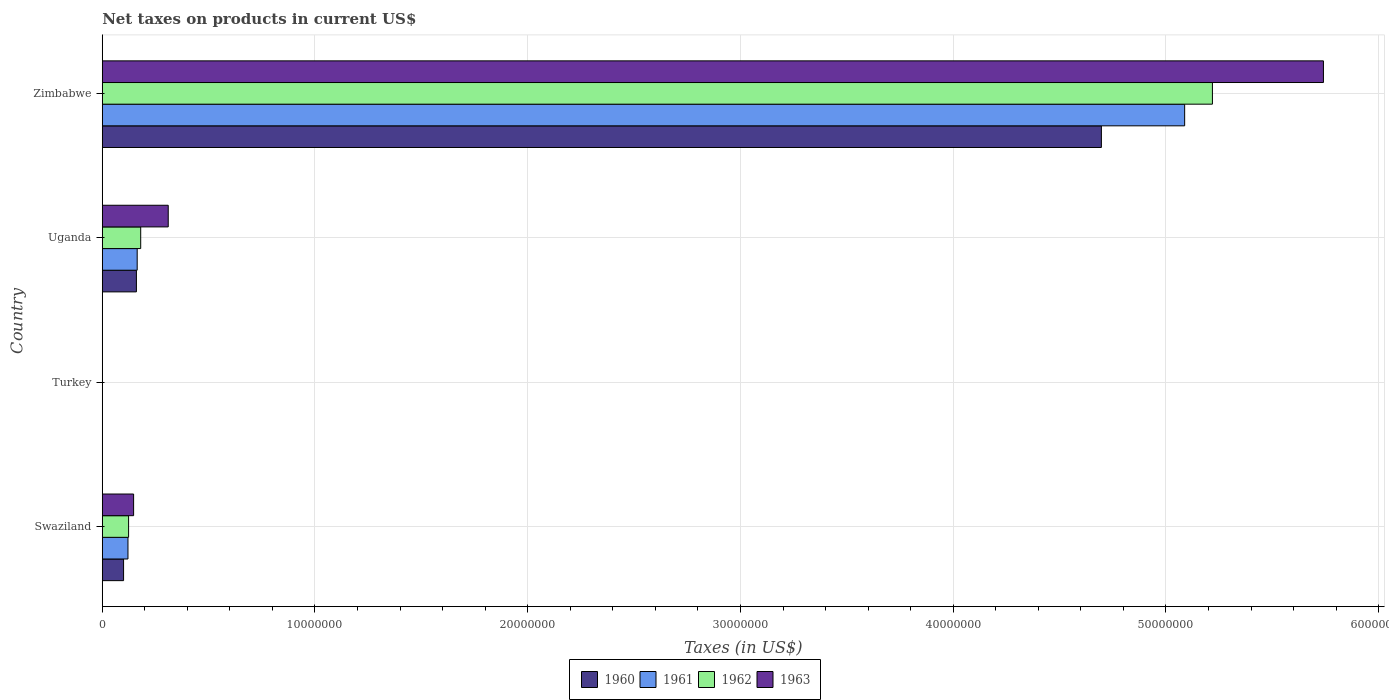How many different coloured bars are there?
Offer a terse response. 4. Are the number of bars per tick equal to the number of legend labels?
Keep it short and to the point. Yes. Are the number of bars on each tick of the Y-axis equal?
Offer a terse response. Yes. How many bars are there on the 1st tick from the top?
Make the answer very short. 4. What is the label of the 2nd group of bars from the top?
Give a very brief answer. Uganda. What is the net taxes on products in 1962 in Turkey?
Your answer should be compact. 1600. Across all countries, what is the maximum net taxes on products in 1963?
Provide a short and direct response. 5.74e+07. Across all countries, what is the minimum net taxes on products in 1960?
Offer a terse response. 1300. In which country was the net taxes on products in 1962 maximum?
Offer a terse response. Zimbabwe. What is the total net taxes on products in 1963 in the graph?
Offer a very short reply. 6.20e+07. What is the difference between the net taxes on products in 1963 in Swaziland and that in Zimbabwe?
Your answer should be very brief. -5.59e+07. What is the difference between the net taxes on products in 1963 in Zimbabwe and the net taxes on products in 1961 in Turkey?
Provide a succinct answer. 5.74e+07. What is the average net taxes on products in 1963 per country?
Your answer should be very brief. 1.55e+07. What is the difference between the net taxes on products in 1963 and net taxes on products in 1962 in Swaziland?
Offer a very short reply. 2.36e+05. In how many countries, is the net taxes on products in 1961 greater than 34000000 US$?
Your answer should be compact. 1. What is the ratio of the net taxes on products in 1963 in Swaziland to that in Uganda?
Your response must be concise. 0.48. What is the difference between the highest and the second highest net taxes on products in 1960?
Your answer should be very brief. 4.54e+07. What is the difference between the highest and the lowest net taxes on products in 1963?
Offer a very short reply. 5.74e+07. Is the sum of the net taxes on products in 1961 in Turkey and Zimbabwe greater than the maximum net taxes on products in 1962 across all countries?
Your answer should be very brief. No. Is it the case that in every country, the sum of the net taxes on products in 1963 and net taxes on products in 1960 is greater than the sum of net taxes on products in 1962 and net taxes on products in 1961?
Provide a short and direct response. No. What does the 2nd bar from the top in Zimbabwe represents?
Provide a short and direct response. 1962. What does the 2nd bar from the bottom in Swaziland represents?
Give a very brief answer. 1961. Is it the case that in every country, the sum of the net taxes on products in 1960 and net taxes on products in 1961 is greater than the net taxes on products in 1963?
Give a very brief answer. Yes. How many bars are there?
Offer a very short reply. 16. Are all the bars in the graph horizontal?
Your answer should be compact. Yes. How many countries are there in the graph?
Make the answer very short. 4. What is the difference between two consecutive major ticks on the X-axis?
Ensure brevity in your answer.  1.00e+07. Does the graph contain grids?
Offer a terse response. Yes. Where does the legend appear in the graph?
Your answer should be compact. Bottom center. How many legend labels are there?
Offer a very short reply. 4. How are the legend labels stacked?
Your answer should be compact. Horizontal. What is the title of the graph?
Provide a short and direct response. Net taxes on products in current US$. Does "1991" appear as one of the legend labels in the graph?
Make the answer very short. No. What is the label or title of the X-axis?
Your answer should be very brief. Taxes (in US$). What is the Taxes (in US$) in 1960 in Swaziland?
Offer a terse response. 1.00e+06. What is the Taxes (in US$) in 1961 in Swaziland?
Keep it short and to the point. 1.21e+06. What is the Taxes (in US$) of 1962 in Swaziland?
Your answer should be very brief. 1.24e+06. What is the Taxes (in US$) of 1963 in Swaziland?
Give a very brief answer. 1.47e+06. What is the Taxes (in US$) of 1960 in Turkey?
Offer a terse response. 1300. What is the Taxes (in US$) in 1961 in Turkey?
Keep it short and to the point. 1500. What is the Taxes (in US$) of 1962 in Turkey?
Provide a short and direct response. 1600. What is the Taxes (in US$) in 1963 in Turkey?
Your answer should be very brief. 1800. What is the Taxes (in US$) of 1960 in Uganda?
Make the answer very short. 1.61e+06. What is the Taxes (in US$) in 1961 in Uganda?
Your response must be concise. 1.64e+06. What is the Taxes (in US$) in 1962 in Uganda?
Provide a short and direct response. 1.81e+06. What is the Taxes (in US$) of 1963 in Uganda?
Provide a short and direct response. 3.10e+06. What is the Taxes (in US$) in 1960 in Zimbabwe?
Provide a succinct answer. 4.70e+07. What is the Taxes (in US$) of 1961 in Zimbabwe?
Offer a terse response. 5.09e+07. What is the Taxes (in US$) in 1962 in Zimbabwe?
Keep it short and to the point. 5.22e+07. What is the Taxes (in US$) in 1963 in Zimbabwe?
Your answer should be very brief. 5.74e+07. Across all countries, what is the maximum Taxes (in US$) in 1960?
Provide a short and direct response. 4.70e+07. Across all countries, what is the maximum Taxes (in US$) of 1961?
Make the answer very short. 5.09e+07. Across all countries, what is the maximum Taxes (in US$) in 1962?
Your response must be concise. 5.22e+07. Across all countries, what is the maximum Taxes (in US$) of 1963?
Provide a short and direct response. 5.74e+07. Across all countries, what is the minimum Taxes (in US$) of 1960?
Provide a succinct answer. 1300. Across all countries, what is the minimum Taxes (in US$) in 1961?
Offer a terse response. 1500. Across all countries, what is the minimum Taxes (in US$) of 1962?
Your response must be concise. 1600. Across all countries, what is the minimum Taxes (in US$) of 1963?
Ensure brevity in your answer.  1800. What is the total Taxes (in US$) of 1960 in the graph?
Give a very brief answer. 4.96e+07. What is the total Taxes (in US$) of 1961 in the graph?
Your answer should be compact. 5.37e+07. What is the total Taxes (in US$) of 1962 in the graph?
Keep it short and to the point. 5.52e+07. What is the total Taxes (in US$) of 1963 in the graph?
Offer a terse response. 6.20e+07. What is the difference between the Taxes (in US$) in 1960 in Swaziland and that in Turkey?
Keep it short and to the point. 1.00e+06. What is the difference between the Taxes (in US$) in 1961 in Swaziland and that in Turkey?
Offer a very short reply. 1.21e+06. What is the difference between the Taxes (in US$) of 1962 in Swaziland and that in Turkey?
Give a very brief answer. 1.24e+06. What is the difference between the Taxes (in US$) of 1963 in Swaziland and that in Turkey?
Provide a succinct answer. 1.47e+06. What is the difference between the Taxes (in US$) in 1960 in Swaziland and that in Uganda?
Your answer should be very brief. -6.03e+05. What is the difference between the Taxes (in US$) in 1961 in Swaziland and that in Uganda?
Your response must be concise. -4.34e+05. What is the difference between the Taxes (in US$) in 1962 in Swaziland and that in Uganda?
Your response must be concise. -5.69e+05. What is the difference between the Taxes (in US$) of 1963 in Swaziland and that in Uganda?
Keep it short and to the point. -1.63e+06. What is the difference between the Taxes (in US$) in 1960 in Swaziland and that in Zimbabwe?
Give a very brief answer. -4.60e+07. What is the difference between the Taxes (in US$) of 1961 in Swaziland and that in Zimbabwe?
Your answer should be compact. -4.97e+07. What is the difference between the Taxes (in US$) of 1962 in Swaziland and that in Zimbabwe?
Your answer should be compact. -5.09e+07. What is the difference between the Taxes (in US$) in 1963 in Swaziland and that in Zimbabwe?
Provide a short and direct response. -5.59e+07. What is the difference between the Taxes (in US$) of 1960 in Turkey and that in Uganda?
Ensure brevity in your answer.  -1.60e+06. What is the difference between the Taxes (in US$) of 1961 in Turkey and that in Uganda?
Make the answer very short. -1.64e+06. What is the difference between the Taxes (in US$) in 1962 in Turkey and that in Uganda?
Your response must be concise. -1.81e+06. What is the difference between the Taxes (in US$) in 1963 in Turkey and that in Uganda?
Provide a succinct answer. -3.10e+06. What is the difference between the Taxes (in US$) in 1960 in Turkey and that in Zimbabwe?
Keep it short and to the point. -4.70e+07. What is the difference between the Taxes (in US$) in 1961 in Turkey and that in Zimbabwe?
Keep it short and to the point. -5.09e+07. What is the difference between the Taxes (in US$) of 1962 in Turkey and that in Zimbabwe?
Ensure brevity in your answer.  -5.22e+07. What is the difference between the Taxes (in US$) of 1963 in Turkey and that in Zimbabwe?
Give a very brief answer. -5.74e+07. What is the difference between the Taxes (in US$) of 1960 in Uganda and that in Zimbabwe?
Provide a short and direct response. -4.54e+07. What is the difference between the Taxes (in US$) of 1961 in Uganda and that in Zimbabwe?
Provide a short and direct response. -4.92e+07. What is the difference between the Taxes (in US$) of 1962 in Uganda and that in Zimbabwe?
Provide a succinct answer. -5.04e+07. What is the difference between the Taxes (in US$) in 1963 in Uganda and that in Zimbabwe?
Provide a short and direct response. -5.43e+07. What is the difference between the Taxes (in US$) in 1960 in Swaziland and the Taxes (in US$) in 1961 in Turkey?
Your answer should be very brief. 1.00e+06. What is the difference between the Taxes (in US$) in 1960 in Swaziland and the Taxes (in US$) in 1962 in Turkey?
Ensure brevity in your answer.  1.00e+06. What is the difference between the Taxes (in US$) of 1960 in Swaziland and the Taxes (in US$) of 1963 in Turkey?
Keep it short and to the point. 1.00e+06. What is the difference between the Taxes (in US$) of 1961 in Swaziland and the Taxes (in US$) of 1962 in Turkey?
Offer a terse response. 1.21e+06. What is the difference between the Taxes (in US$) of 1961 in Swaziland and the Taxes (in US$) of 1963 in Turkey?
Provide a short and direct response. 1.21e+06. What is the difference between the Taxes (in US$) of 1962 in Swaziland and the Taxes (in US$) of 1963 in Turkey?
Provide a succinct answer. 1.24e+06. What is the difference between the Taxes (in US$) of 1960 in Swaziland and the Taxes (in US$) of 1961 in Uganda?
Your answer should be very brief. -6.40e+05. What is the difference between the Taxes (in US$) in 1960 in Swaziland and the Taxes (in US$) in 1962 in Uganda?
Your answer should be compact. -8.05e+05. What is the difference between the Taxes (in US$) of 1960 in Swaziland and the Taxes (in US$) of 1963 in Uganda?
Offer a very short reply. -2.10e+06. What is the difference between the Taxes (in US$) in 1961 in Swaziland and the Taxes (in US$) in 1962 in Uganda?
Provide a succinct answer. -5.99e+05. What is the difference between the Taxes (in US$) in 1961 in Swaziland and the Taxes (in US$) in 1963 in Uganda?
Make the answer very short. -1.89e+06. What is the difference between the Taxes (in US$) in 1962 in Swaziland and the Taxes (in US$) in 1963 in Uganda?
Make the answer very short. -1.86e+06. What is the difference between the Taxes (in US$) in 1960 in Swaziland and the Taxes (in US$) in 1961 in Zimbabwe?
Provide a short and direct response. -4.99e+07. What is the difference between the Taxes (in US$) of 1960 in Swaziland and the Taxes (in US$) of 1962 in Zimbabwe?
Ensure brevity in your answer.  -5.12e+07. What is the difference between the Taxes (in US$) in 1960 in Swaziland and the Taxes (in US$) in 1963 in Zimbabwe?
Offer a terse response. -5.64e+07. What is the difference between the Taxes (in US$) of 1961 in Swaziland and the Taxes (in US$) of 1962 in Zimbabwe?
Your response must be concise. -5.10e+07. What is the difference between the Taxes (in US$) in 1961 in Swaziland and the Taxes (in US$) in 1963 in Zimbabwe?
Provide a succinct answer. -5.62e+07. What is the difference between the Taxes (in US$) of 1962 in Swaziland and the Taxes (in US$) of 1963 in Zimbabwe?
Keep it short and to the point. -5.62e+07. What is the difference between the Taxes (in US$) in 1960 in Turkey and the Taxes (in US$) in 1961 in Uganda?
Offer a terse response. -1.64e+06. What is the difference between the Taxes (in US$) of 1960 in Turkey and the Taxes (in US$) of 1962 in Uganda?
Your answer should be very brief. -1.81e+06. What is the difference between the Taxes (in US$) in 1960 in Turkey and the Taxes (in US$) in 1963 in Uganda?
Provide a succinct answer. -3.10e+06. What is the difference between the Taxes (in US$) of 1961 in Turkey and the Taxes (in US$) of 1962 in Uganda?
Give a very brief answer. -1.81e+06. What is the difference between the Taxes (in US$) in 1961 in Turkey and the Taxes (in US$) in 1963 in Uganda?
Provide a succinct answer. -3.10e+06. What is the difference between the Taxes (in US$) of 1962 in Turkey and the Taxes (in US$) of 1963 in Uganda?
Your response must be concise. -3.10e+06. What is the difference between the Taxes (in US$) of 1960 in Turkey and the Taxes (in US$) of 1961 in Zimbabwe?
Your answer should be very brief. -5.09e+07. What is the difference between the Taxes (in US$) of 1960 in Turkey and the Taxes (in US$) of 1962 in Zimbabwe?
Provide a succinct answer. -5.22e+07. What is the difference between the Taxes (in US$) of 1960 in Turkey and the Taxes (in US$) of 1963 in Zimbabwe?
Your response must be concise. -5.74e+07. What is the difference between the Taxes (in US$) in 1961 in Turkey and the Taxes (in US$) in 1962 in Zimbabwe?
Make the answer very short. -5.22e+07. What is the difference between the Taxes (in US$) of 1961 in Turkey and the Taxes (in US$) of 1963 in Zimbabwe?
Provide a short and direct response. -5.74e+07. What is the difference between the Taxes (in US$) in 1962 in Turkey and the Taxes (in US$) in 1963 in Zimbabwe?
Make the answer very short. -5.74e+07. What is the difference between the Taxes (in US$) of 1960 in Uganda and the Taxes (in US$) of 1961 in Zimbabwe?
Offer a terse response. -4.93e+07. What is the difference between the Taxes (in US$) of 1960 in Uganda and the Taxes (in US$) of 1962 in Zimbabwe?
Ensure brevity in your answer.  -5.06e+07. What is the difference between the Taxes (in US$) in 1960 in Uganda and the Taxes (in US$) in 1963 in Zimbabwe?
Make the answer very short. -5.58e+07. What is the difference between the Taxes (in US$) of 1961 in Uganda and the Taxes (in US$) of 1962 in Zimbabwe?
Make the answer very short. -5.05e+07. What is the difference between the Taxes (in US$) of 1961 in Uganda and the Taxes (in US$) of 1963 in Zimbabwe?
Make the answer very short. -5.58e+07. What is the difference between the Taxes (in US$) of 1962 in Uganda and the Taxes (in US$) of 1963 in Zimbabwe?
Your answer should be compact. -5.56e+07. What is the average Taxes (in US$) of 1960 per country?
Provide a short and direct response. 1.24e+07. What is the average Taxes (in US$) in 1961 per country?
Your response must be concise. 1.34e+07. What is the average Taxes (in US$) in 1962 per country?
Your answer should be very brief. 1.38e+07. What is the average Taxes (in US$) in 1963 per country?
Ensure brevity in your answer.  1.55e+07. What is the difference between the Taxes (in US$) of 1960 and Taxes (in US$) of 1961 in Swaziland?
Your response must be concise. -2.06e+05. What is the difference between the Taxes (in US$) of 1960 and Taxes (in US$) of 1962 in Swaziland?
Keep it short and to the point. -2.36e+05. What is the difference between the Taxes (in US$) in 1960 and Taxes (in US$) in 1963 in Swaziland?
Offer a terse response. -4.72e+05. What is the difference between the Taxes (in US$) of 1961 and Taxes (in US$) of 1962 in Swaziland?
Make the answer very short. -2.95e+04. What is the difference between the Taxes (in US$) of 1961 and Taxes (in US$) of 1963 in Swaziland?
Give a very brief answer. -2.65e+05. What is the difference between the Taxes (in US$) in 1962 and Taxes (in US$) in 1963 in Swaziland?
Offer a terse response. -2.36e+05. What is the difference between the Taxes (in US$) in 1960 and Taxes (in US$) in 1961 in Turkey?
Provide a succinct answer. -200. What is the difference between the Taxes (in US$) of 1960 and Taxes (in US$) of 1962 in Turkey?
Offer a very short reply. -300. What is the difference between the Taxes (in US$) of 1960 and Taxes (in US$) of 1963 in Turkey?
Your response must be concise. -500. What is the difference between the Taxes (in US$) in 1961 and Taxes (in US$) in 1962 in Turkey?
Your answer should be compact. -100. What is the difference between the Taxes (in US$) of 1961 and Taxes (in US$) of 1963 in Turkey?
Offer a very short reply. -300. What is the difference between the Taxes (in US$) in 1962 and Taxes (in US$) in 1963 in Turkey?
Your response must be concise. -200. What is the difference between the Taxes (in US$) in 1960 and Taxes (in US$) in 1961 in Uganda?
Your answer should be compact. -3.67e+04. What is the difference between the Taxes (in US$) in 1960 and Taxes (in US$) in 1962 in Uganda?
Make the answer very short. -2.02e+05. What is the difference between the Taxes (in US$) in 1960 and Taxes (in US$) in 1963 in Uganda?
Provide a succinct answer. -1.50e+06. What is the difference between the Taxes (in US$) in 1961 and Taxes (in US$) in 1962 in Uganda?
Your answer should be compact. -1.65e+05. What is the difference between the Taxes (in US$) in 1961 and Taxes (in US$) in 1963 in Uganda?
Keep it short and to the point. -1.46e+06. What is the difference between the Taxes (in US$) in 1962 and Taxes (in US$) in 1963 in Uganda?
Give a very brief answer. -1.29e+06. What is the difference between the Taxes (in US$) in 1960 and Taxes (in US$) in 1961 in Zimbabwe?
Your response must be concise. -3.91e+06. What is the difference between the Taxes (in US$) of 1960 and Taxes (in US$) of 1962 in Zimbabwe?
Make the answer very short. -5.22e+06. What is the difference between the Taxes (in US$) in 1960 and Taxes (in US$) in 1963 in Zimbabwe?
Provide a short and direct response. -1.04e+07. What is the difference between the Taxes (in US$) in 1961 and Taxes (in US$) in 1962 in Zimbabwe?
Ensure brevity in your answer.  -1.30e+06. What is the difference between the Taxes (in US$) in 1961 and Taxes (in US$) in 1963 in Zimbabwe?
Your answer should be compact. -6.52e+06. What is the difference between the Taxes (in US$) in 1962 and Taxes (in US$) in 1963 in Zimbabwe?
Keep it short and to the point. -5.22e+06. What is the ratio of the Taxes (in US$) in 1960 in Swaziland to that in Turkey?
Provide a succinct answer. 771.23. What is the ratio of the Taxes (in US$) in 1961 in Swaziland to that in Turkey?
Your answer should be compact. 806. What is the ratio of the Taxes (in US$) in 1962 in Swaziland to that in Turkey?
Make the answer very short. 774.06. What is the ratio of the Taxes (in US$) of 1963 in Swaziland to that in Turkey?
Ensure brevity in your answer.  819.11. What is the ratio of the Taxes (in US$) of 1960 in Swaziland to that in Uganda?
Your response must be concise. 0.62. What is the ratio of the Taxes (in US$) in 1961 in Swaziland to that in Uganda?
Make the answer very short. 0.74. What is the ratio of the Taxes (in US$) of 1962 in Swaziland to that in Uganda?
Provide a short and direct response. 0.69. What is the ratio of the Taxes (in US$) of 1963 in Swaziland to that in Uganda?
Your answer should be compact. 0.48. What is the ratio of the Taxes (in US$) in 1960 in Swaziland to that in Zimbabwe?
Provide a succinct answer. 0.02. What is the ratio of the Taxes (in US$) in 1961 in Swaziland to that in Zimbabwe?
Keep it short and to the point. 0.02. What is the ratio of the Taxes (in US$) of 1962 in Swaziland to that in Zimbabwe?
Give a very brief answer. 0.02. What is the ratio of the Taxes (in US$) of 1963 in Swaziland to that in Zimbabwe?
Provide a succinct answer. 0.03. What is the ratio of the Taxes (in US$) in 1960 in Turkey to that in Uganda?
Keep it short and to the point. 0. What is the ratio of the Taxes (in US$) of 1961 in Turkey to that in Uganda?
Ensure brevity in your answer.  0. What is the ratio of the Taxes (in US$) of 1962 in Turkey to that in Uganda?
Provide a succinct answer. 0. What is the ratio of the Taxes (in US$) in 1963 in Turkey to that in Uganda?
Ensure brevity in your answer.  0. What is the ratio of the Taxes (in US$) of 1961 in Turkey to that in Zimbabwe?
Your answer should be very brief. 0. What is the ratio of the Taxes (in US$) in 1963 in Turkey to that in Zimbabwe?
Keep it short and to the point. 0. What is the ratio of the Taxes (in US$) in 1960 in Uganda to that in Zimbabwe?
Give a very brief answer. 0.03. What is the ratio of the Taxes (in US$) of 1961 in Uganda to that in Zimbabwe?
Offer a very short reply. 0.03. What is the ratio of the Taxes (in US$) in 1962 in Uganda to that in Zimbabwe?
Ensure brevity in your answer.  0.03. What is the ratio of the Taxes (in US$) in 1963 in Uganda to that in Zimbabwe?
Your response must be concise. 0.05. What is the difference between the highest and the second highest Taxes (in US$) in 1960?
Your response must be concise. 4.54e+07. What is the difference between the highest and the second highest Taxes (in US$) in 1961?
Make the answer very short. 4.92e+07. What is the difference between the highest and the second highest Taxes (in US$) in 1962?
Give a very brief answer. 5.04e+07. What is the difference between the highest and the second highest Taxes (in US$) of 1963?
Your answer should be compact. 5.43e+07. What is the difference between the highest and the lowest Taxes (in US$) of 1960?
Make the answer very short. 4.70e+07. What is the difference between the highest and the lowest Taxes (in US$) in 1961?
Your answer should be very brief. 5.09e+07. What is the difference between the highest and the lowest Taxes (in US$) of 1962?
Ensure brevity in your answer.  5.22e+07. What is the difference between the highest and the lowest Taxes (in US$) of 1963?
Make the answer very short. 5.74e+07. 